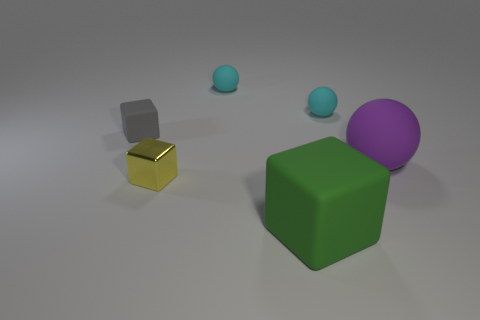Add 2 small things. How many objects exist? 8 Add 4 cylinders. How many cylinders exist? 4 Subtract 1 yellow cubes. How many objects are left? 5 Subtract all large gray rubber cubes. Subtract all cyan balls. How many objects are left? 4 Add 2 yellow cubes. How many yellow cubes are left? 3 